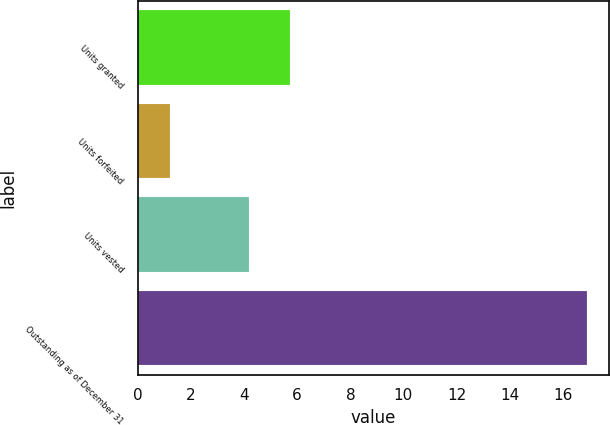Convert chart. <chart><loc_0><loc_0><loc_500><loc_500><bar_chart><fcel>Units granted<fcel>Units forfeited<fcel>Units vested<fcel>Outstanding as of December 31<nl><fcel>5.71<fcel>1.2<fcel>4.2<fcel>16.91<nl></chart> 